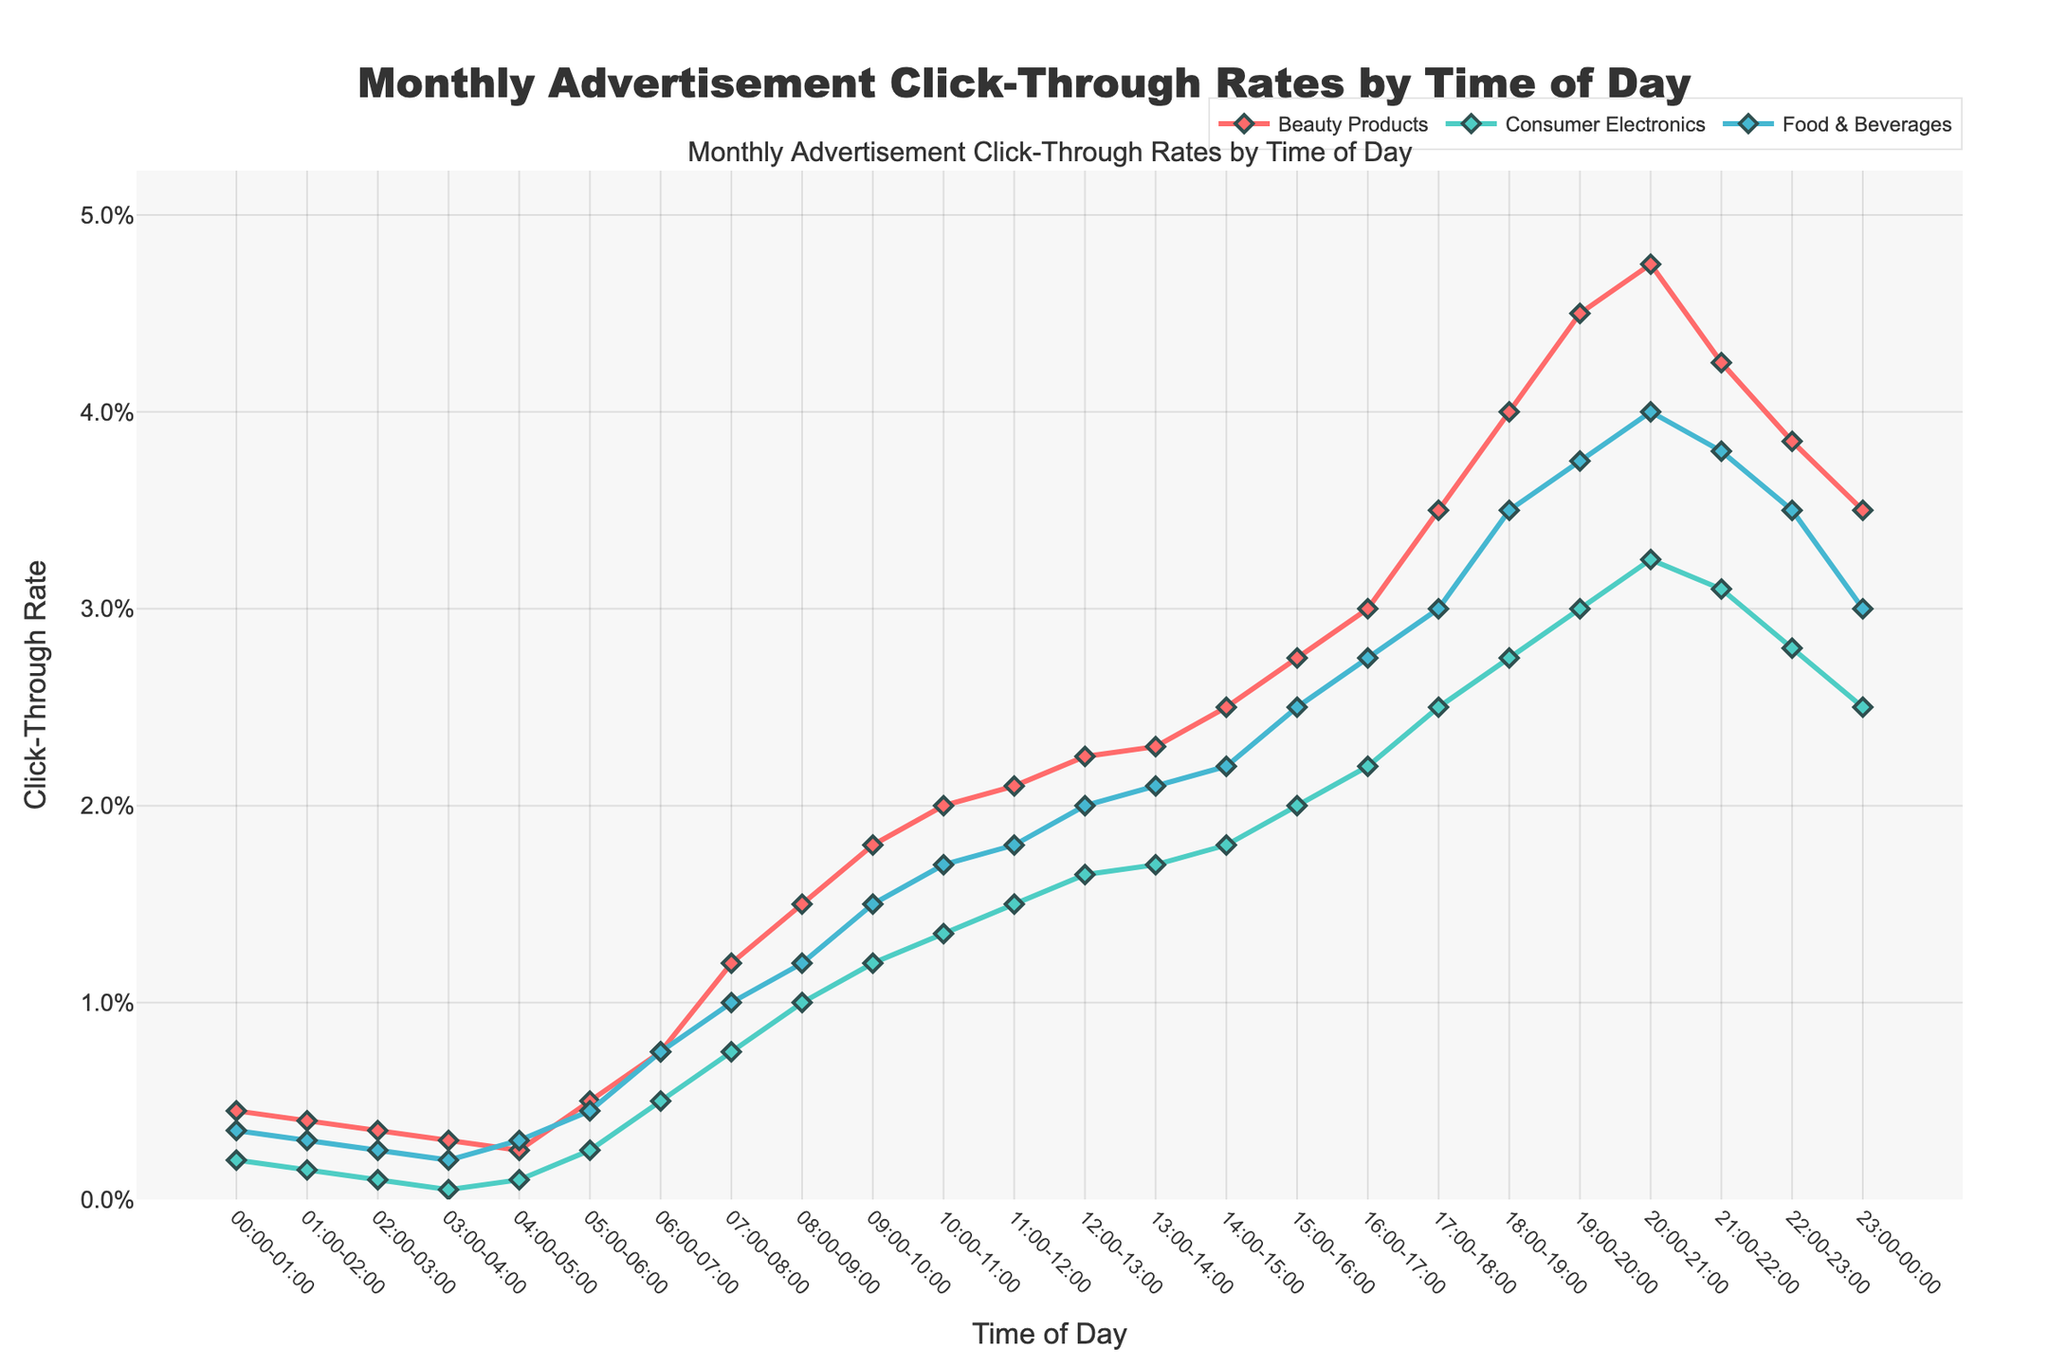What time of day has the highest click-through rate for Beauty Products? To determine this, observe the plot for Beauty Products and note the peak point on the y-axis. The highest point appears around 20:00-21:00.
Answer: 20:00-21:00 What product category has the lowest click-through rate at 18:00-19:00? Compare click-through rates for each product category at the time frame of 18:00-19:00 by looking at that specific data point for each category. Consumer Electronics has the lowest rate here.
Answer: Consumer Electronics During which hour does Food & Beverages category witness the steepest increase in click-through rate? Identify the hour with the sharpest upward slope for the Food & Beverages' line in the plot. The biggest jump is from 17:00 to 18:00.
Answer: 17:00-18:00 How does the click-through rate for Consumer Electronics change from 21:00-22:00 to 22:00-23:00? Check the plot for Consumer Electronics between 21:00-22:00 and 22:00-23:00. It decreases from 3.10% to 2.80%.
Answer: Decreases Which product category has the highest average click-through rate over the entire day? Calculate the average click-through rate for each category and compare the results. Beauty Products consistently show higher rates throughout the day.
Answer: Beauty Products What is the total click-through rate increase for Beauty Products from 09:00-10:00 to 15:00-16:00? Find the click-through rates at the two times, then calculate the difference: 2.75% - 1.80% = 0.95%.
Answer: 0.95% Compare the click-through rates of all product categories at 07:00-08:00. Which category performs best? Review the 07:00-08:00 time frame for all categories in the plot. Beauty Products have the highest rate at this time.
Answer: Beauty Products How does the click-through rate for Food & Beverages at 12:00-13:00 compare to that for Beauty Products at the same time? Look at 12:00-13:00 for both categories. Food & Beverages has 2.00%, while Beauty Products have 2.25%. Hence, Beauty Products perform better by 0.25%.
Answer: Beauty Products perform better by 0.25% What are the click-through rates for each category at midnight (00:00-01:00)? Refer to the plot at 00:00-01:00 for each category. Beauty Products: 0.45%, Consumer Electronics: 0.20%, Food & Beverages: 0.35%.
Answer: 0.45%, 0.20%, 0.35% Which product category experiences the most consistent click-through rate throughout the day without significant spikes? Examine the lines' slopes and variations. Consumer Electronics' line appears most consistent.
Answer: Consumer Electronics 